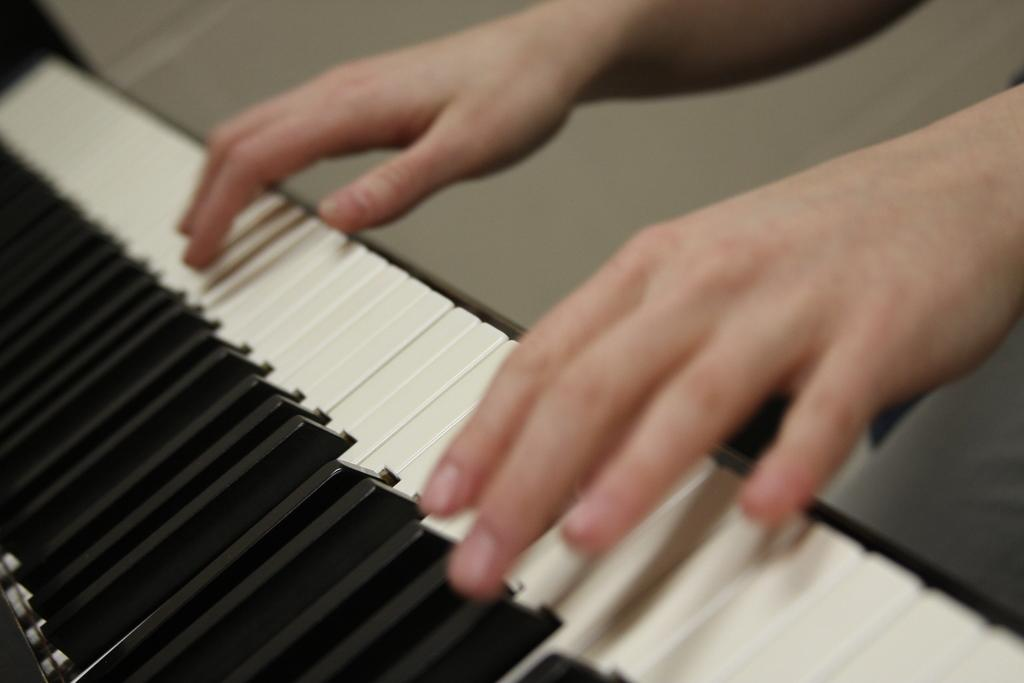What is the main subject of the image? There is a person in the image. What is the person doing in the image? The person is playing a piano. What type of breakfast is the person eating while playing the piano in the image? There is no breakfast present in the image; the person is solely focused on playing the piano. 